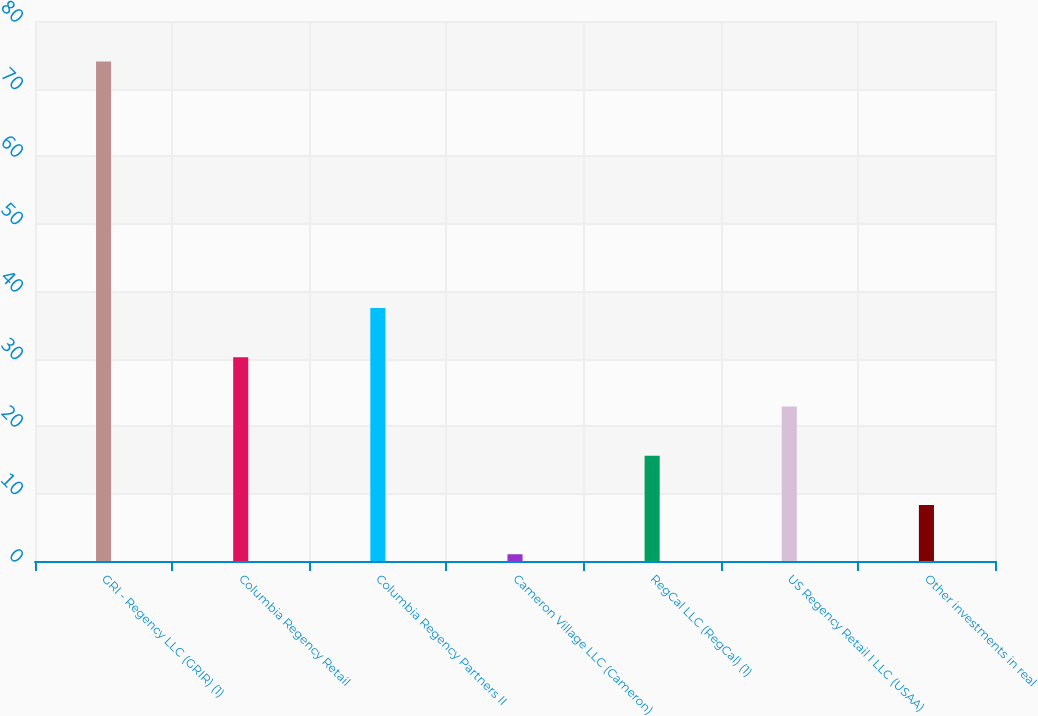<chart> <loc_0><loc_0><loc_500><loc_500><bar_chart><fcel>GRI - Regency LLC (GRIR) (1)<fcel>Columbia Regency Retail<fcel>Columbia Regency Partners II<fcel>Cameron Village LLC (Cameron)<fcel>RegCal LLC (RegCal) (1)<fcel>US Regency Retail I LLC (USAA)<fcel>Other investments in real<nl><fcel>74<fcel>30.2<fcel>37.5<fcel>1<fcel>15.6<fcel>22.9<fcel>8.3<nl></chart> 